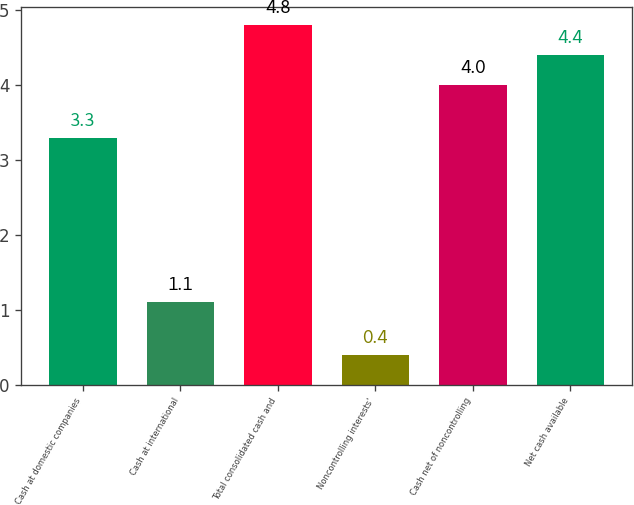<chart> <loc_0><loc_0><loc_500><loc_500><bar_chart><fcel>Cash at domestic companies<fcel>Cash at international<fcel>Total consolidated cash and<fcel>Noncontrolling interests'<fcel>Cash net of noncontrolling<fcel>Net cash available<nl><fcel>3.3<fcel>1.1<fcel>4.8<fcel>0.4<fcel>4<fcel>4.4<nl></chart> 